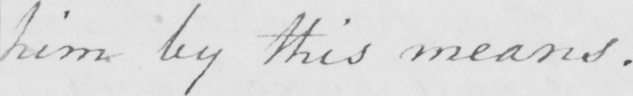What is written in this line of handwriting? him by this means . 